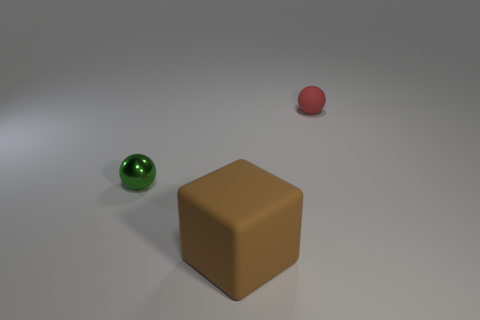The small matte sphere has what color?
Your answer should be compact. Red. Do the rubber ball that is behind the brown thing and the matte cube have the same color?
Give a very brief answer. No. What color is the other thing that is the same shape as the red thing?
Ensure brevity in your answer.  Green. How many big things are blocks or red balls?
Your answer should be very brief. 1. There is a rubber thing in front of the red thing; what size is it?
Your response must be concise. Large. Are there any other shiny spheres that have the same color as the shiny sphere?
Ensure brevity in your answer.  No. Is the tiny matte ball the same color as the large thing?
Ensure brevity in your answer.  No. What number of red objects are on the right side of the tiny sphere that is behind the metal object?
Your answer should be very brief. 0. How many large blocks are the same material as the small red thing?
Provide a succinct answer. 1. There is a tiny rubber sphere; are there any matte spheres to the left of it?
Keep it short and to the point. No. 